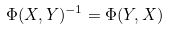<formula> <loc_0><loc_0><loc_500><loc_500>\Phi ( X , Y ) ^ { - 1 } = \Phi ( Y , X )</formula> 